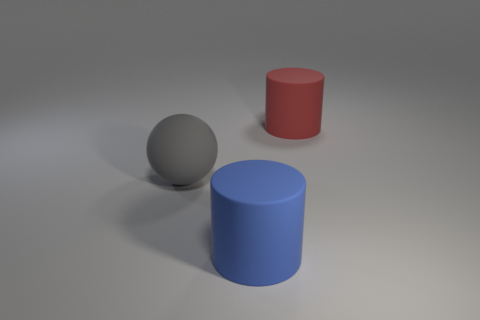Subtract all red cylinders. How many cylinders are left? 1 Add 2 big red objects. How many objects exist? 5 Subtract 1 spheres. How many spheres are left? 0 Subtract all spheres. How many objects are left? 2 Subtract all red cylinders. How many cyan spheres are left? 0 Subtract all gray balls. Subtract all large gray spheres. How many objects are left? 1 Add 3 gray rubber objects. How many gray rubber objects are left? 4 Add 1 brown cubes. How many brown cubes exist? 1 Subtract 1 blue cylinders. How many objects are left? 2 Subtract all cyan cylinders. Subtract all red cubes. How many cylinders are left? 2 